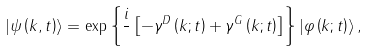Convert formula to latex. <formula><loc_0><loc_0><loc_500><loc_500>\left | \psi \left ( k , t \right ) \right \rangle = \exp \left \{ \frac { i } { } \left [ - \gamma ^ { D } \left ( k ; t \right ) + \gamma ^ { G } \left ( k ; t \right ) \right ] \right \} \left | \varphi \left ( k ; t \right ) \right \rangle ,</formula> 